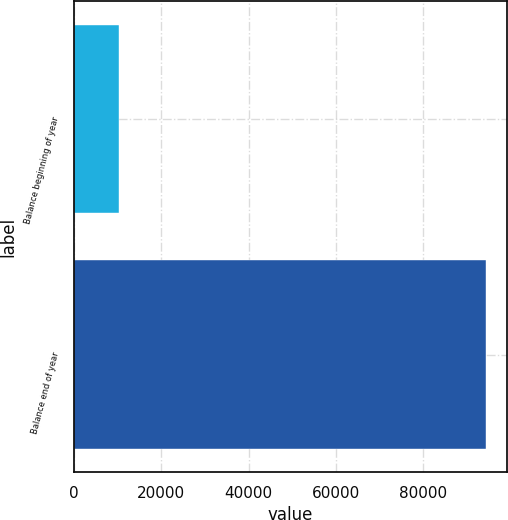Convert chart. <chart><loc_0><loc_0><loc_500><loc_500><bar_chart><fcel>Balance beginning of year<fcel>Balance end of year<nl><fcel>10258<fcel>94417<nl></chart> 